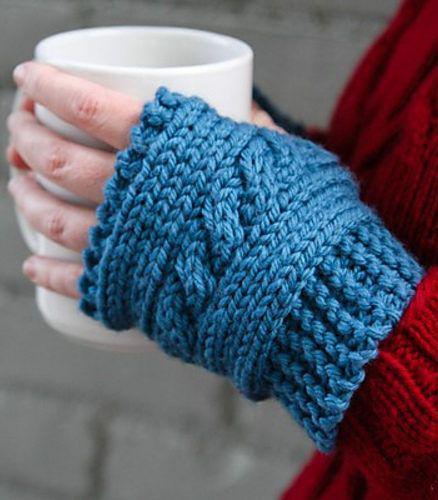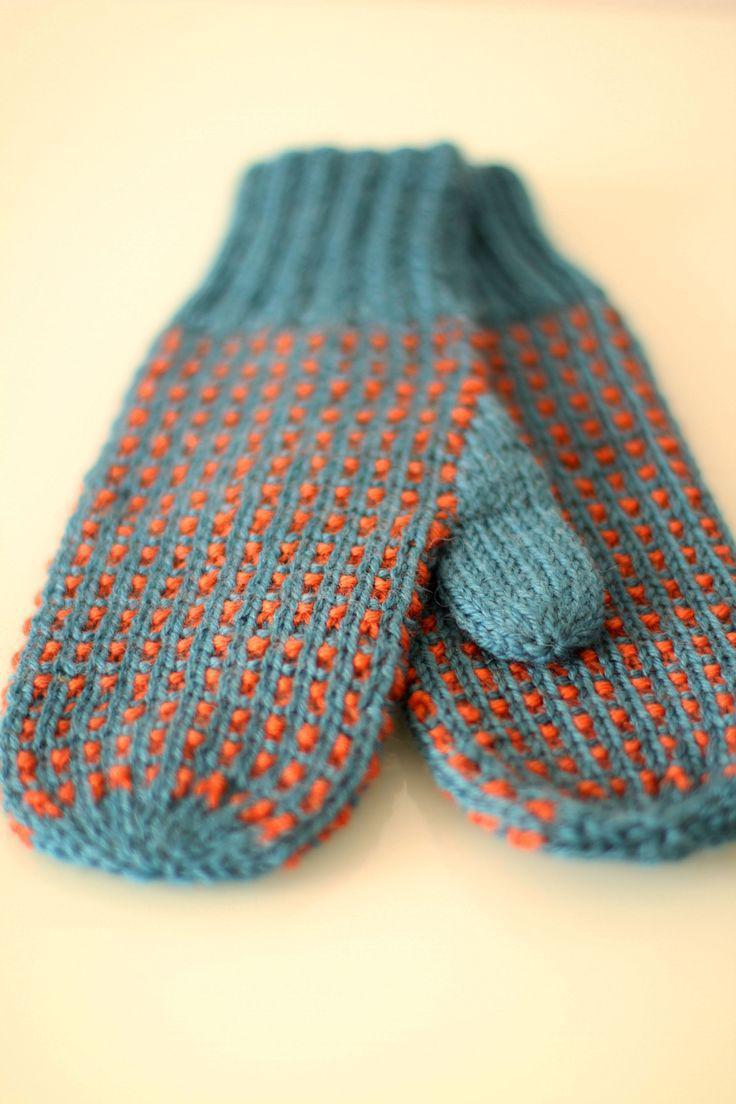The first image is the image on the left, the second image is the image on the right. Assess this claim about the two images: "In one of the images there is a single mitten worn on an empty hand.". Correct or not? Answer yes or no. No. The first image is the image on the left, the second image is the image on the right. Evaluate the accuracy of this statement regarding the images: "An image includes a hand wearing a solid-blue fingerless mitten.". Is it true? Answer yes or no. Yes. 